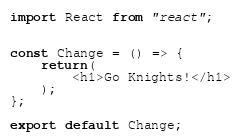Convert code to text. <code><loc_0><loc_0><loc_500><loc_500><_JavaScript_>import React from "react";


const Change = () => {
    return(
        <h1>Go Knights!</h1>
    );
};

export default Change;</code> 